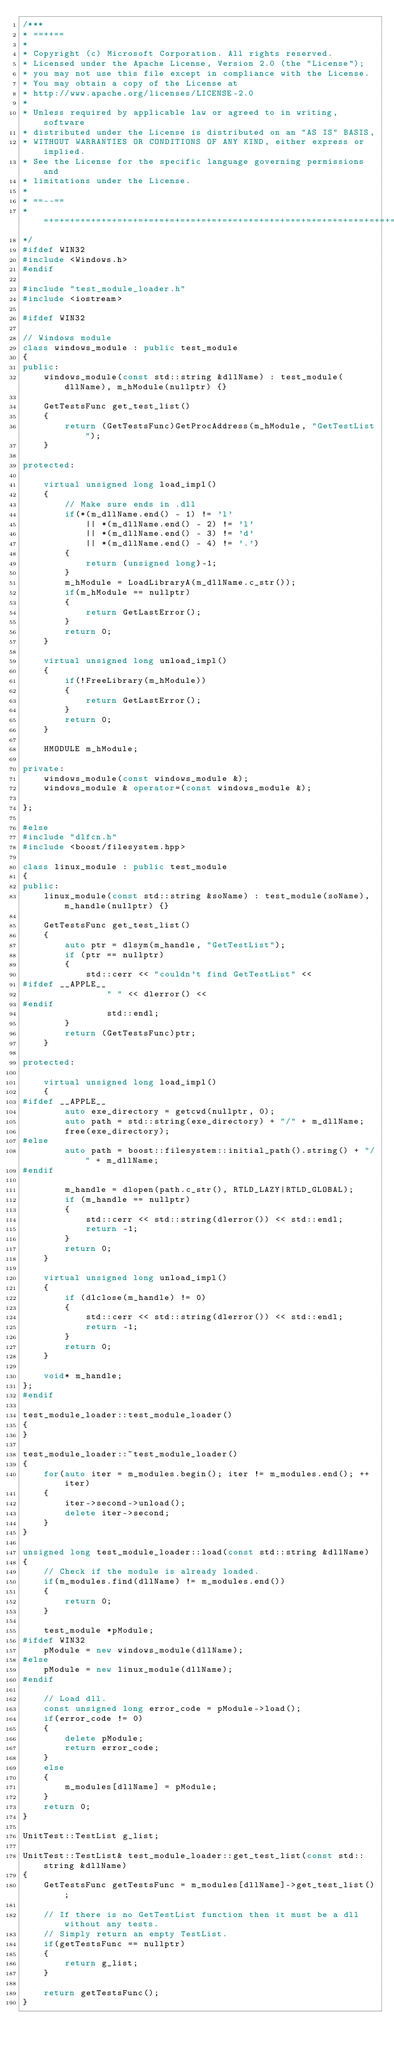<code> <loc_0><loc_0><loc_500><loc_500><_C++_>/***
* ==++==
*
* Copyright (c) Microsoft Corporation. All rights reserved. 
* Licensed under the Apache License, Version 2.0 (the "License");
* you may not use this file except in compliance with the License.
* You may obtain a copy of the License at
* http://www.apache.org/licenses/LICENSE-2.0
* 
* Unless required by applicable law or agreed to in writing, software
* distributed under the License is distributed on an "AS IS" BASIS,
* WITHOUT WARRANTIES OR CONDITIONS OF ANY KIND, either express or implied.
* See the License for the specific language governing permissions and
* limitations under the License.
*
* ==--==
* =+=+=+=+=+=+=+=+=+=+=+=+=+=+=+=+=+=+=+=+=+=+=+=+=+=+=+=+=+=+=+=+=+=+=+=+=+=+=+=+=+=+=+=+=+=+=+=+=+=+=+=+=+=+=+=+
*/
#ifdef WIN32
#include <Windows.h>
#endif

#include "test_module_loader.h"
#include <iostream>

#ifdef WIN32

// Windows module
class windows_module : public test_module
{
public:
    windows_module(const std::string &dllName) : test_module(dllName), m_hModule(nullptr) {}

    GetTestsFunc get_test_list()
    {
        return (GetTestsFunc)GetProcAddress(m_hModule, "GetTestList");
    }

protected:

    virtual unsigned long load_impl()
    {
        // Make sure ends in .dll
        if(*(m_dllName.end() - 1) != 'l' 
            || *(m_dllName.end() - 2) != 'l' 
            || *(m_dllName.end() - 3) != 'd' 
            || *(m_dllName.end() - 4) != '.')
        {
            return (unsigned long)-1;
        }
        m_hModule = LoadLibraryA(m_dllName.c_str());
        if(m_hModule == nullptr)
        {
            return GetLastError();
        }
        return 0;
    }

    virtual unsigned long unload_impl()
    {
        if(!FreeLibrary(m_hModule))
        {
            return GetLastError();
        }
        return 0;
    }

    HMODULE m_hModule;

private:
	windows_module(const windows_module &);
	windows_module & operator=(const windows_module &);

};

#else
#include "dlfcn.h"
#include <boost/filesystem.hpp>

class linux_module : public test_module
{
public:
    linux_module(const std::string &soName) : test_module(soName), m_handle(nullptr) {}

    GetTestsFunc get_test_list()
    {
        auto ptr = dlsym(m_handle, "GetTestList");
        if (ptr == nullptr)
        {
            std::cerr << "couldn't find GetTestList" <<
#ifdef __APPLE__
                " " << dlerror() <<
#endif
                std::endl;
        }
        return (GetTestsFunc)ptr;
    }

protected:

    virtual unsigned long load_impl()
    {
#ifdef __APPLE__
        auto exe_directory = getcwd(nullptr, 0);
        auto path = std::string(exe_directory) + "/" + m_dllName;
        free(exe_directory);
#else
        auto path = boost::filesystem::initial_path().string() + "/" + m_dllName;
#endif

        m_handle = dlopen(path.c_str(), RTLD_LAZY|RTLD_GLOBAL);
        if (m_handle == nullptr)
        {
            std::cerr << std::string(dlerror()) << std::endl;
            return -1;
        }
        return 0;
    }

    virtual unsigned long unload_impl()
    {
        if (dlclose(m_handle) != 0)
        {
            std::cerr << std::string(dlerror()) << std::endl;
            return -1;
        }
        return 0;
    }

    void* m_handle;
};
#endif

test_module_loader::test_module_loader()
{
}

test_module_loader::~test_module_loader()
{
    for(auto iter = m_modules.begin(); iter != m_modules.end(); ++iter)
    {
        iter->second->unload();
        delete iter->second;
    }
}

unsigned long test_module_loader::load(const std::string &dllName)
{
    // Check if the module is already loaded.
    if(m_modules.find(dllName) != m_modules.end())
    {
        return 0;
    }

    test_module *pModule;
#ifdef WIN32
    pModule = new windows_module(dllName);
#else
    pModule = new linux_module(dllName);
#endif

    // Load dll.
    const unsigned long error_code = pModule->load();
    if(error_code != 0)
    {
        delete pModule;
        return error_code;
    }
    else
    {
        m_modules[dllName] = pModule;
    }
    return 0;
}

UnitTest::TestList g_list;

UnitTest::TestList& test_module_loader::get_test_list(const std::string &dllName)
{
    GetTestsFunc getTestsFunc = m_modules[dllName]->get_test_list();

    // If there is no GetTestList function then it must be a dll without any tests.
    // Simply return an empty TestList.
    if(getTestsFunc == nullptr)
    {
        return g_list;
    }

    return getTestsFunc();
}
</code> 